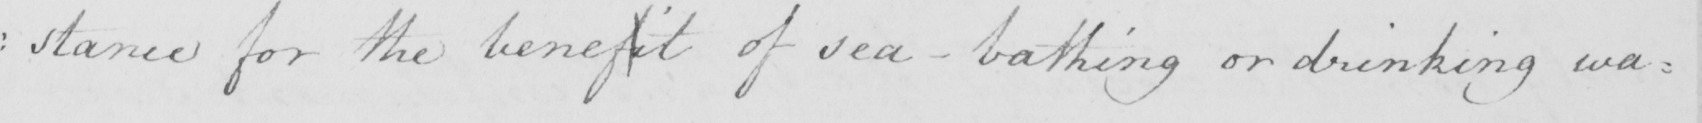Please transcribe the handwritten text in this image. : stance for the benefit of sea-bathing or drinking wa= 